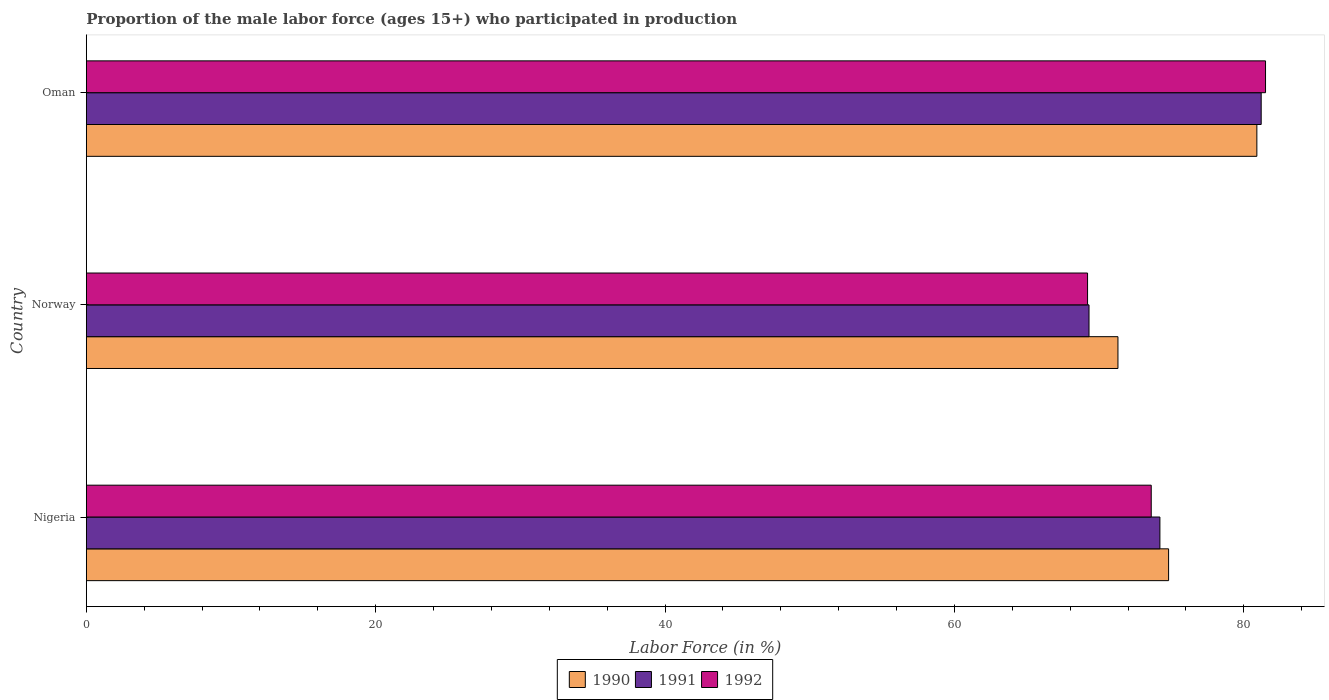How many different coloured bars are there?
Your answer should be compact. 3. How many bars are there on the 2nd tick from the top?
Make the answer very short. 3. How many bars are there on the 1st tick from the bottom?
Provide a short and direct response. 3. What is the label of the 1st group of bars from the top?
Make the answer very short. Oman. In how many cases, is the number of bars for a given country not equal to the number of legend labels?
Offer a terse response. 0. What is the proportion of the male labor force who participated in production in 1990 in Norway?
Keep it short and to the point. 71.3. Across all countries, what is the maximum proportion of the male labor force who participated in production in 1990?
Keep it short and to the point. 80.9. Across all countries, what is the minimum proportion of the male labor force who participated in production in 1990?
Give a very brief answer. 71.3. In which country was the proportion of the male labor force who participated in production in 1990 maximum?
Ensure brevity in your answer.  Oman. What is the total proportion of the male labor force who participated in production in 1991 in the graph?
Provide a succinct answer. 224.7. What is the difference between the proportion of the male labor force who participated in production in 1991 in Nigeria and that in Norway?
Your response must be concise. 4.9. What is the difference between the proportion of the male labor force who participated in production in 1992 in Oman and the proportion of the male labor force who participated in production in 1991 in Nigeria?
Make the answer very short. 7.3. What is the average proportion of the male labor force who participated in production in 1990 per country?
Your answer should be very brief. 75.67. What is the difference between the proportion of the male labor force who participated in production in 1992 and proportion of the male labor force who participated in production in 1990 in Norway?
Provide a short and direct response. -2.1. In how many countries, is the proportion of the male labor force who participated in production in 1990 greater than 80 %?
Offer a terse response. 1. What is the ratio of the proportion of the male labor force who participated in production in 1991 in Norway to that in Oman?
Offer a terse response. 0.85. Is the proportion of the male labor force who participated in production in 1991 in Norway less than that in Oman?
Offer a terse response. Yes. What is the difference between the highest and the second highest proportion of the male labor force who participated in production in 1992?
Keep it short and to the point. 7.9. What is the difference between the highest and the lowest proportion of the male labor force who participated in production in 1990?
Offer a terse response. 9.6. What does the 2nd bar from the top in Oman represents?
Your response must be concise. 1991. Is it the case that in every country, the sum of the proportion of the male labor force who participated in production in 1991 and proportion of the male labor force who participated in production in 1990 is greater than the proportion of the male labor force who participated in production in 1992?
Provide a short and direct response. Yes. How many bars are there?
Give a very brief answer. 9. Are all the bars in the graph horizontal?
Keep it short and to the point. Yes. How many countries are there in the graph?
Make the answer very short. 3. What is the difference between two consecutive major ticks on the X-axis?
Offer a very short reply. 20. Are the values on the major ticks of X-axis written in scientific E-notation?
Your answer should be compact. No. Does the graph contain any zero values?
Give a very brief answer. No. Where does the legend appear in the graph?
Offer a terse response. Bottom center. What is the title of the graph?
Provide a short and direct response. Proportion of the male labor force (ages 15+) who participated in production. What is the Labor Force (in %) in 1990 in Nigeria?
Your answer should be compact. 74.8. What is the Labor Force (in %) of 1991 in Nigeria?
Offer a very short reply. 74.2. What is the Labor Force (in %) in 1992 in Nigeria?
Give a very brief answer. 73.6. What is the Labor Force (in %) in 1990 in Norway?
Your answer should be compact. 71.3. What is the Labor Force (in %) of 1991 in Norway?
Your response must be concise. 69.3. What is the Labor Force (in %) in 1992 in Norway?
Provide a short and direct response. 69.2. What is the Labor Force (in %) in 1990 in Oman?
Offer a terse response. 80.9. What is the Labor Force (in %) in 1991 in Oman?
Give a very brief answer. 81.2. What is the Labor Force (in %) in 1992 in Oman?
Your answer should be very brief. 81.5. Across all countries, what is the maximum Labor Force (in %) in 1990?
Offer a terse response. 80.9. Across all countries, what is the maximum Labor Force (in %) of 1991?
Provide a short and direct response. 81.2. Across all countries, what is the maximum Labor Force (in %) of 1992?
Provide a short and direct response. 81.5. Across all countries, what is the minimum Labor Force (in %) in 1990?
Give a very brief answer. 71.3. Across all countries, what is the minimum Labor Force (in %) in 1991?
Make the answer very short. 69.3. Across all countries, what is the minimum Labor Force (in %) of 1992?
Your answer should be very brief. 69.2. What is the total Labor Force (in %) of 1990 in the graph?
Ensure brevity in your answer.  227. What is the total Labor Force (in %) of 1991 in the graph?
Provide a succinct answer. 224.7. What is the total Labor Force (in %) in 1992 in the graph?
Keep it short and to the point. 224.3. What is the difference between the Labor Force (in %) of 1990 in Nigeria and that in Norway?
Ensure brevity in your answer.  3.5. What is the difference between the Labor Force (in %) in 1991 in Nigeria and that in Norway?
Provide a short and direct response. 4.9. What is the difference between the Labor Force (in %) in 1992 in Nigeria and that in Norway?
Offer a terse response. 4.4. What is the difference between the Labor Force (in %) in 1990 in Nigeria and that in Oman?
Your answer should be very brief. -6.1. What is the difference between the Labor Force (in %) in 1991 in Nigeria and that in Oman?
Give a very brief answer. -7. What is the difference between the Labor Force (in %) in 1990 in Norway and that in Oman?
Your answer should be very brief. -9.6. What is the difference between the Labor Force (in %) of 1991 in Norway and that in Oman?
Your response must be concise. -11.9. What is the difference between the Labor Force (in %) in 1990 in Nigeria and the Labor Force (in %) in 1992 in Oman?
Offer a very short reply. -6.7. What is the difference between the Labor Force (in %) in 1991 in Nigeria and the Labor Force (in %) in 1992 in Oman?
Keep it short and to the point. -7.3. What is the difference between the Labor Force (in %) in 1990 in Norway and the Labor Force (in %) in 1991 in Oman?
Your response must be concise. -9.9. What is the difference between the Labor Force (in %) in 1991 in Norway and the Labor Force (in %) in 1992 in Oman?
Keep it short and to the point. -12.2. What is the average Labor Force (in %) of 1990 per country?
Provide a succinct answer. 75.67. What is the average Labor Force (in %) of 1991 per country?
Your answer should be very brief. 74.9. What is the average Labor Force (in %) in 1992 per country?
Your response must be concise. 74.77. What is the difference between the Labor Force (in %) of 1991 and Labor Force (in %) of 1992 in Nigeria?
Your answer should be very brief. 0.6. What is the difference between the Labor Force (in %) of 1990 and Labor Force (in %) of 1992 in Norway?
Make the answer very short. 2.1. What is the difference between the Labor Force (in %) of 1990 and Labor Force (in %) of 1991 in Oman?
Provide a short and direct response. -0.3. What is the difference between the Labor Force (in %) in 1990 and Labor Force (in %) in 1992 in Oman?
Your answer should be very brief. -0.6. What is the difference between the Labor Force (in %) of 1991 and Labor Force (in %) of 1992 in Oman?
Keep it short and to the point. -0.3. What is the ratio of the Labor Force (in %) of 1990 in Nigeria to that in Norway?
Your response must be concise. 1.05. What is the ratio of the Labor Force (in %) in 1991 in Nigeria to that in Norway?
Offer a terse response. 1.07. What is the ratio of the Labor Force (in %) in 1992 in Nigeria to that in Norway?
Your answer should be compact. 1.06. What is the ratio of the Labor Force (in %) of 1990 in Nigeria to that in Oman?
Your answer should be very brief. 0.92. What is the ratio of the Labor Force (in %) of 1991 in Nigeria to that in Oman?
Provide a succinct answer. 0.91. What is the ratio of the Labor Force (in %) of 1992 in Nigeria to that in Oman?
Offer a terse response. 0.9. What is the ratio of the Labor Force (in %) in 1990 in Norway to that in Oman?
Your answer should be very brief. 0.88. What is the ratio of the Labor Force (in %) in 1991 in Norway to that in Oman?
Keep it short and to the point. 0.85. What is the ratio of the Labor Force (in %) in 1992 in Norway to that in Oman?
Your answer should be very brief. 0.85. What is the difference between the highest and the second highest Labor Force (in %) of 1991?
Provide a succinct answer. 7. What is the difference between the highest and the second highest Labor Force (in %) of 1992?
Offer a very short reply. 7.9. What is the difference between the highest and the lowest Labor Force (in %) of 1992?
Ensure brevity in your answer.  12.3. 